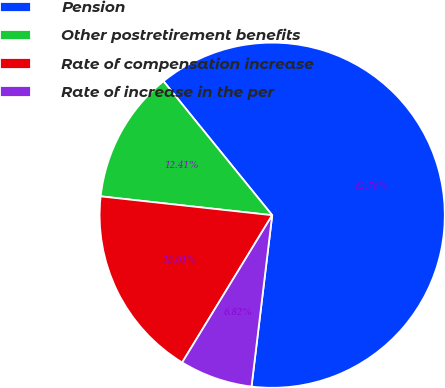Convert chart to OTSL. <chart><loc_0><loc_0><loc_500><loc_500><pie_chart><fcel>Pension<fcel>Other postretirement benefits<fcel>Rate of compensation increase<fcel>Rate of increase in the per<nl><fcel>62.76%<fcel>12.41%<fcel>18.01%<fcel>6.82%<nl></chart> 